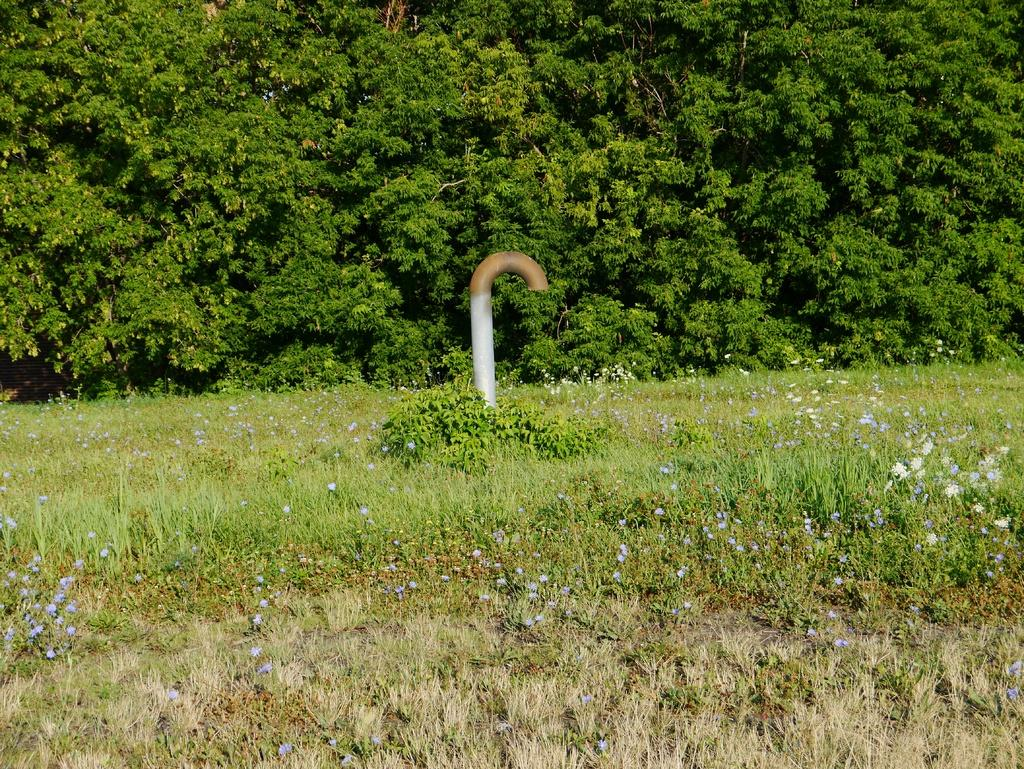What is the main object in the middle of the image? There is a pipe in the middle of the image. What type of vegetation can be seen in the image? There is grass and trees in the image. Can you describe the setting of the image? The image may have been taken in a forest, given the presence of trees and grass. How many rings does the porter carry in the image? There is no porter or rings present in the image. What type of sack is visible in the image? There is no sack present in the image. 